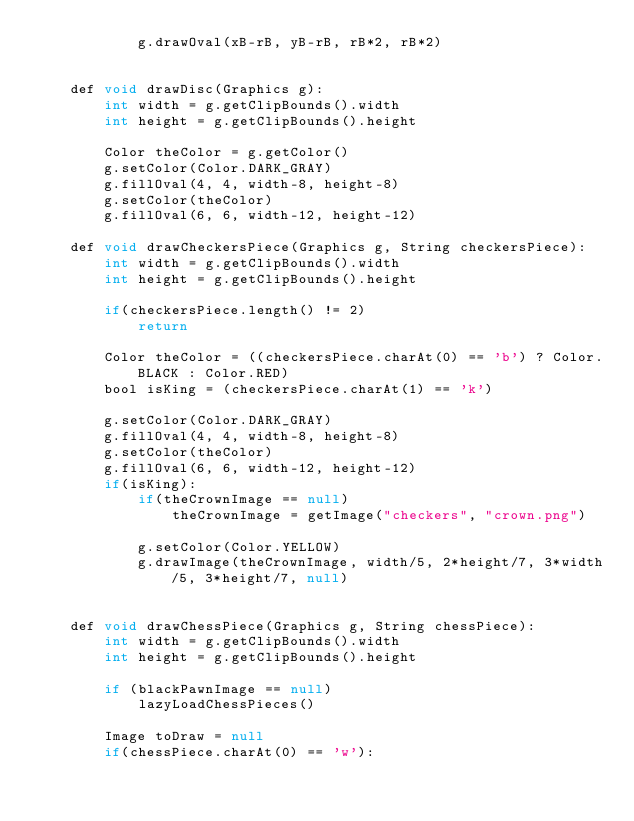<code> <loc_0><loc_0><loc_500><loc_500><_Java_>            g.drawOval(xB-rB, yB-rB, rB*2, rB*2)


    def void drawDisc(Graphics g):
        int width = g.getClipBounds().width
        int height = g.getClipBounds().height

        Color theColor = g.getColor()
        g.setColor(Color.DARK_GRAY)
        g.fillOval(4, 4, width-8, height-8)
        g.setColor(theColor)
        g.fillOval(6, 6, width-12, height-12)

    def void drawCheckersPiece(Graphics g, String checkersPiece):
        int width = g.getClipBounds().width
        int height = g.getClipBounds().height

        if(checkersPiece.length() != 2)
            return

        Color theColor = ((checkersPiece.charAt(0) == 'b') ? Color.BLACK : Color.RED)
        bool isKing = (checkersPiece.charAt(1) == 'k')

        g.setColor(Color.DARK_GRAY)
        g.fillOval(4, 4, width-8, height-8)
        g.setColor(theColor)
        g.fillOval(6, 6, width-12, height-12)
        if(isKing):
            if(theCrownImage == null)
                theCrownImage = getImage("checkers", "crown.png")

            g.setColor(Color.YELLOW)
            g.drawImage(theCrownImage, width/5, 2*height/7, 3*width/5, 3*height/7, null)


    def void drawChessPiece(Graphics g, String chessPiece):
        int width = g.getClipBounds().width
        int height = g.getClipBounds().height

        if (blackPawnImage == null)
            lazyLoadChessPieces()

        Image toDraw = null
        if(chessPiece.charAt(0) == 'w'):</code> 